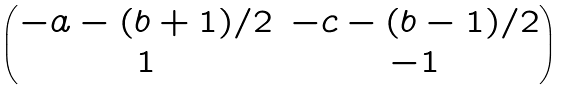<formula> <loc_0><loc_0><loc_500><loc_500>\begin{pmatrix} - a - ( b + 1 ) / 2 & - c - ( b - 1 ) / 2 \\ 1 & - 1 \end{pmatrix}</formula> 